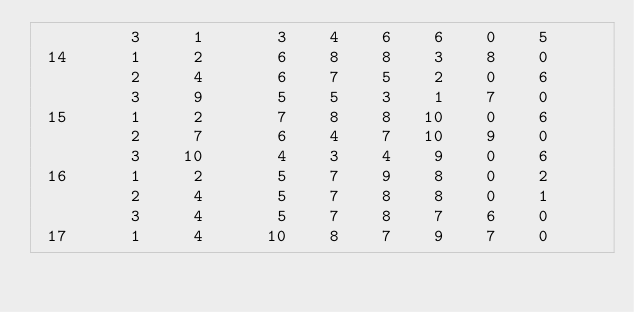Convert code to text. <code><loc_0><loc_0><loc_500><loc_500><_ObjectiveC_>         3     1       3    4    6    6    0    5
 14      1     2       6    8    8    3    8    0
         2     4       6    7    5    2    0    6
         3     9       5    5    3    1    7    0
 15      1     2       7    8    8   10    0    6
         2     7       6    4    7   10    9    0
         3    10       4    3    4    9    0    6
 16      1     2       5    7    9    8    0    2
         2     4       5    7    8    8    0    1
         3     4       5    7    8    7    6    0
 17      1     4      10    8    7    9    7    0</code> 